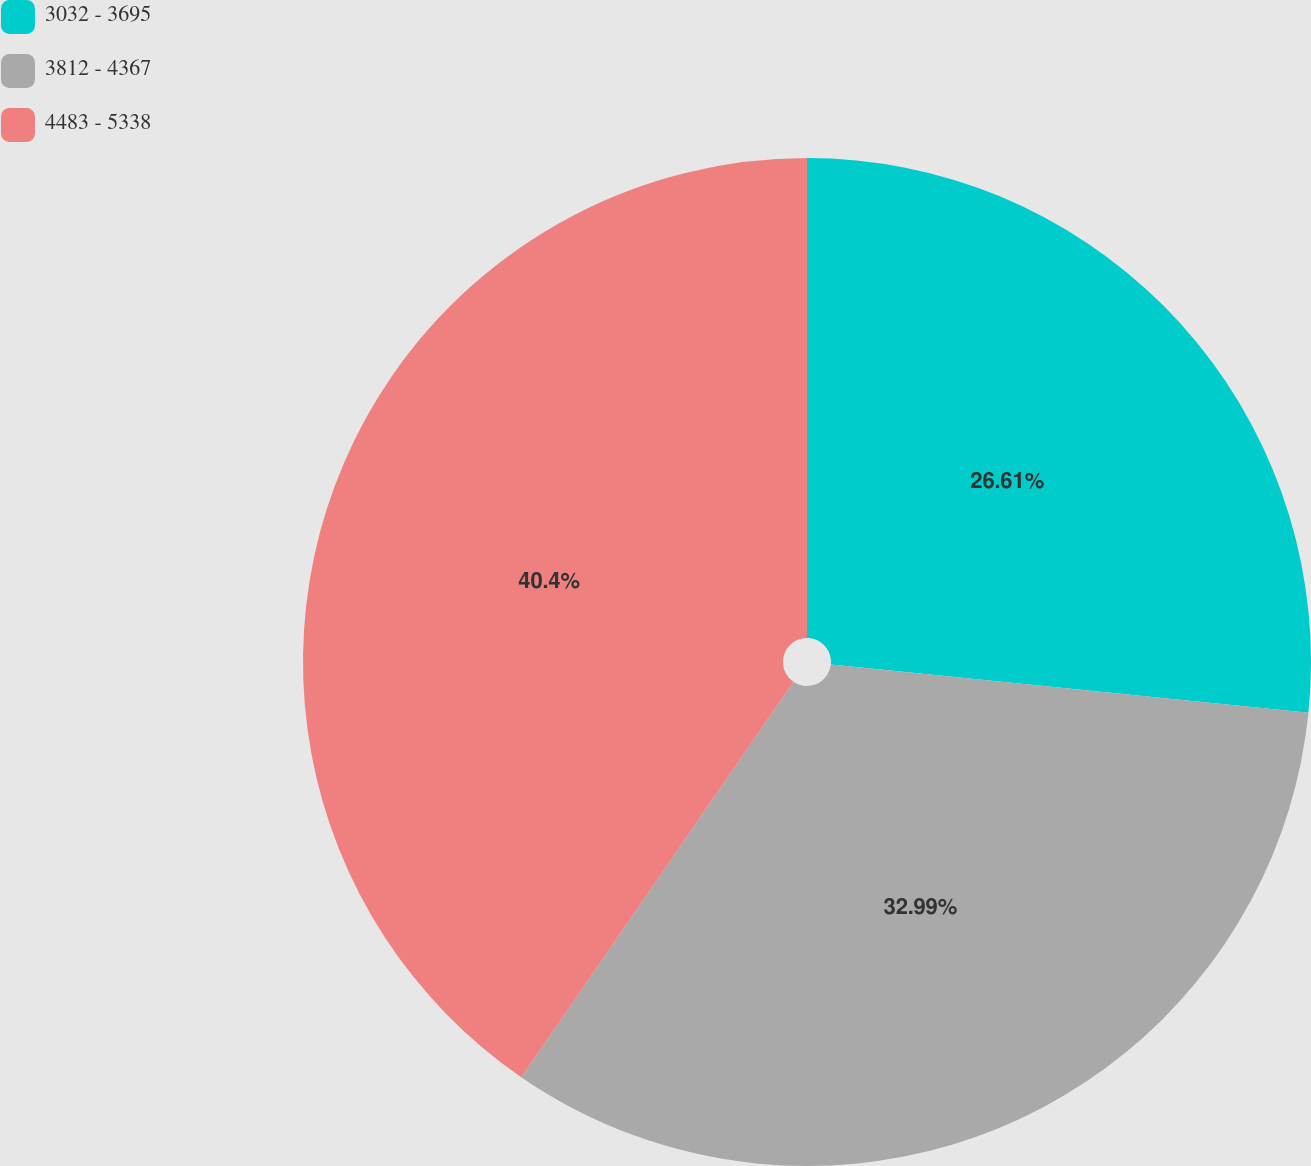Convert chart to OTSL. <chart><loc_0><loc_0><loc_500><loc_500><pie_chart><fcel>3032 - 3695<fcel>3812 - 4367<fcel>4483 - 5338<nl><fcel>26.61%<fcel>32.99%<fcel>40.41%<nl></chart> 